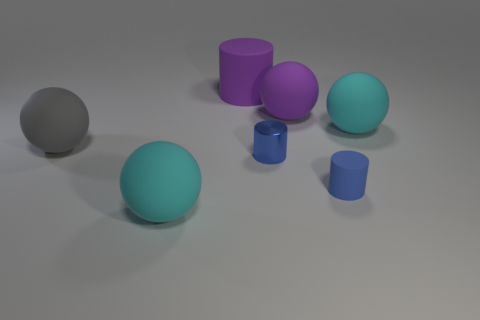Add 1 big gray cubes. How many objects exist? 8 Subtract all cylinders. How many objects are left? 4 Add 6 blue matte cylinders. How many blue matte cylinders are left? 7 Add 6 cyan matte spheres. How many cyan matte spheres exist? 8 Subtract 0 red balls. How many objects are left? 7 Subtract all gray things. Subtract all matte spheres. How many objects are left? 2 